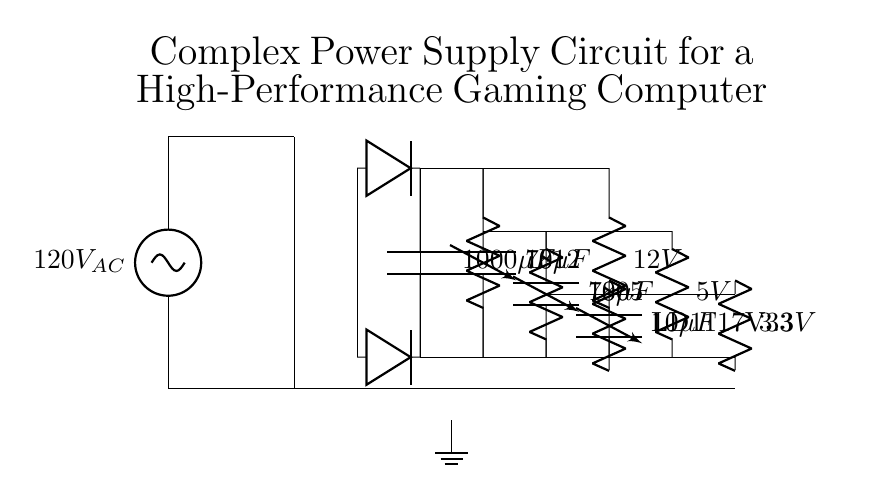What is the input voltage of this circuit? The input voltage from the AC source is labeled as 120V. This is indicated at the beginning of the circuit diagram where the AC input voltage is specified.
Answer: 120V What type of transformer is used in this circuit? The circuit diagram uses a standard transformer symbol, but it does not specify the type or ratings. Therefore, we can only classify it as a transformer without further details.
Answer: Transformer How many voltage regulators are present in the circuit? There are three voltage regulators shown in the circuit, labeled as 7812 for 12V, 7805 for 5V, and LD1117V33 for 3.3V. This count can be verified by identifying each regulator's symbol in the diagram.
Answer: Three What is the output voltage of the 5V regulator? The output voltage of the 5V regulator is labeled clearly in the diagram. This regulator is marked as 7805, which signifies that its output voltage is 5 volts.
Answer: 5V Which component is used for smoothing the output voltage? The smoothing capacitor is identified as a capacitor with a capacitance of 1000μF, located after the rectifier circuit. Its purpose is to reduce voltage ripple and stabilize the output.
Answer: 1000μF capacitor What is the common ground reference point in this circuit? In the circuit, the ground reference point is marked at the bottom, where the ground symbol is shown. It connects all the negative references of the various components together, ensuring a common voltage level.
Answer: Ground What is the purpose of the output capacitors? The output capacitors (10μF) are shown for each output voltage (5V, 3.3V) to filter and stabilize the output, reducing noise and ensuring smoother power delivery to the load.
Answer: Stabilizing output voltage 